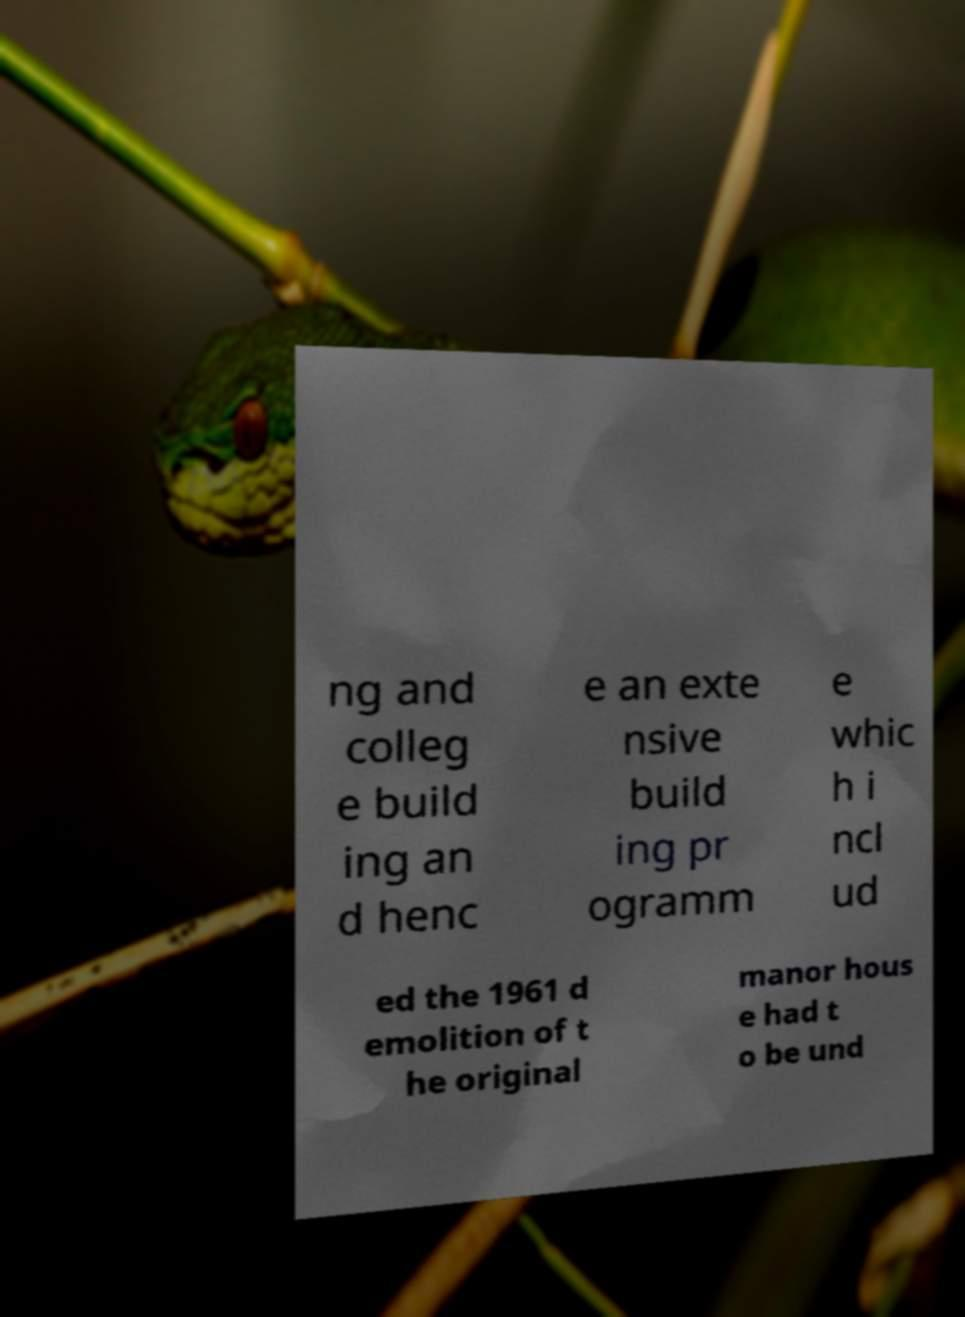Please identify and transcribe the text found in this image. ng and colleg e build ing an d henc e an exte nsive build ing pr ogramm e whic h i ncl ud ed the 1961 d emolition of t he original manor hous e had t o be und 